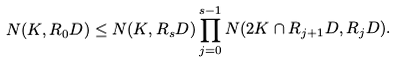Convert formula to latex. <formula><loc_0><loc_0><loc_500><loc_500>N ( K , R _ { 0 } D ) \leq N ( K , R _ { s } D ) \prod _ { j = 0 } ^ { s - 1 } N ( 2 K \cap R _ { j + 1 } D , R _ { j } D ) .</formula> 